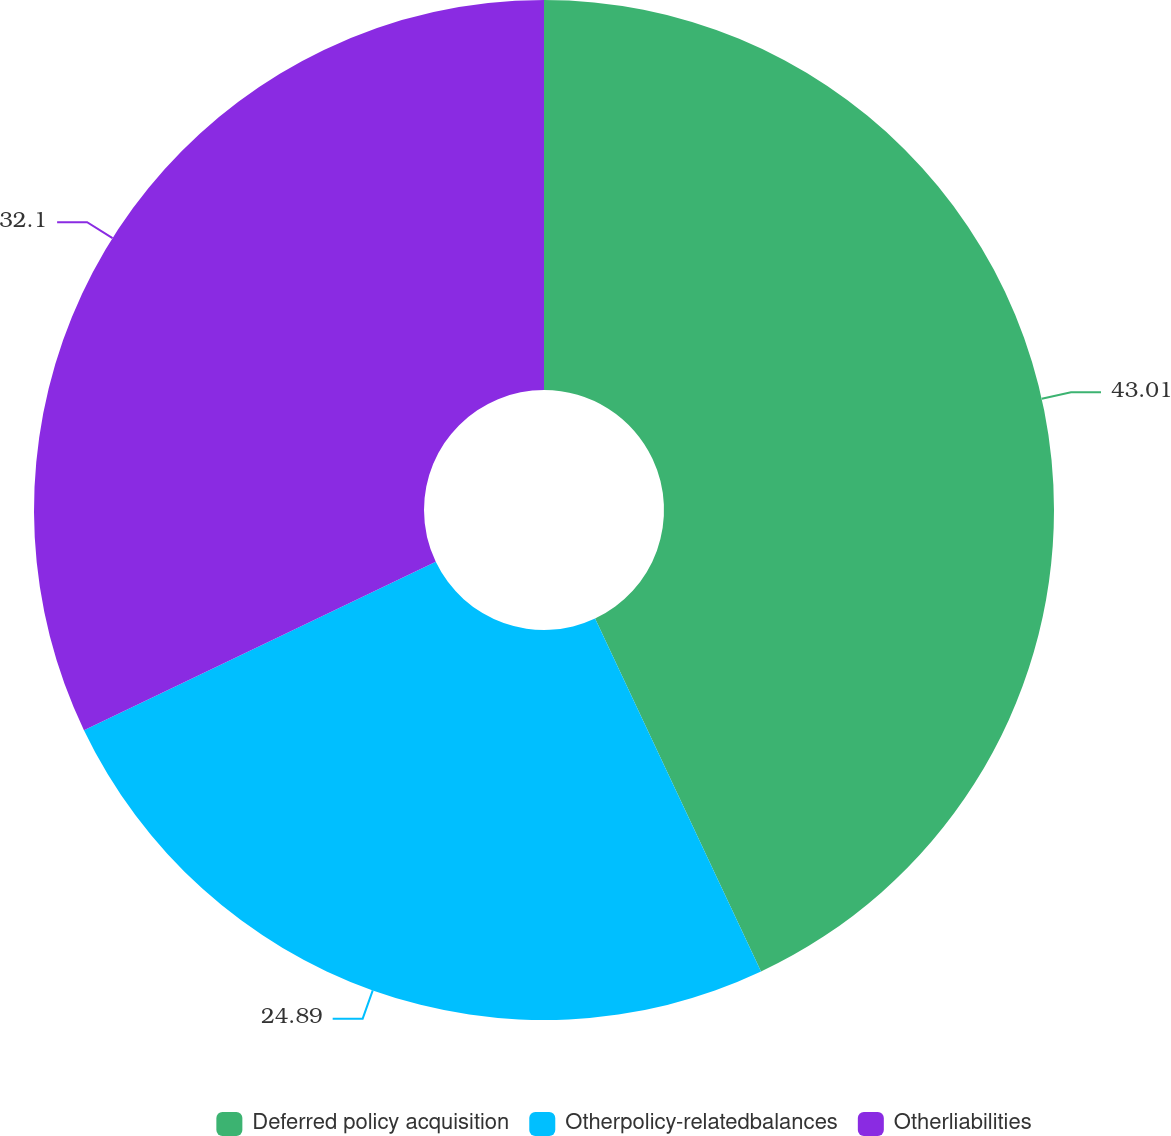<chart> <loc_0><loc_0><loc_500><loc_500><pie_chart><fcel>Deferred policy acquisition<fcel>Otherpolicy-relatedbalances<fcel>Otherliabilities<nl><fcel>43.0%<fcel>24.89%<fcel>32.1%<nl></chart> 